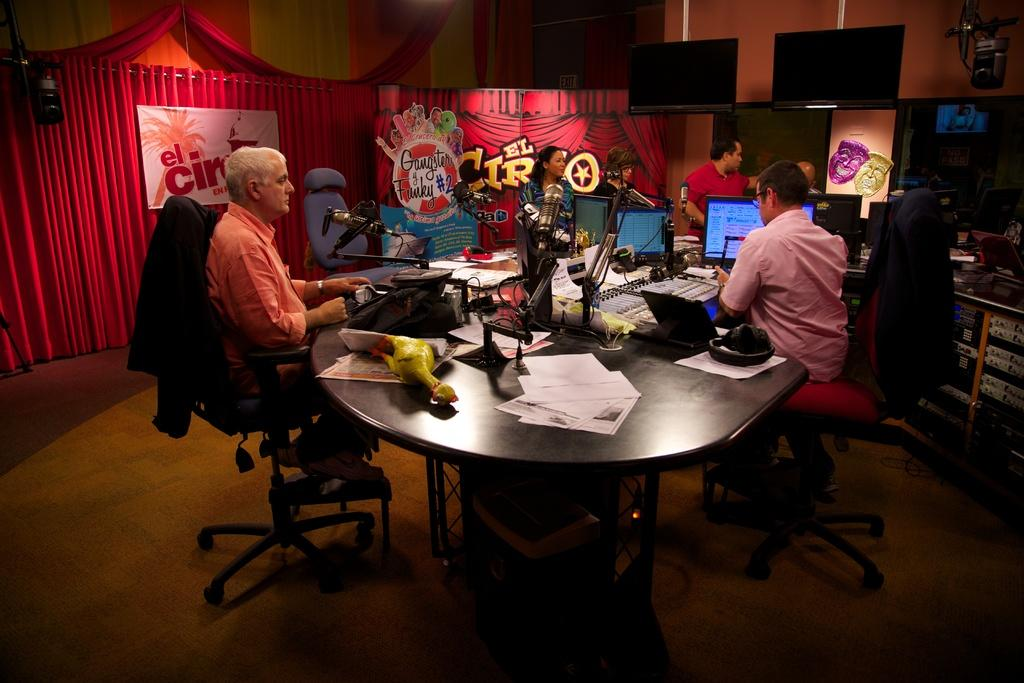What is the main piece of furniture in the image? There is a table in the image. What is on the table? There are many papers on the table. Where are the people sitting in relation to the table? There are people sitting on both the left and right sides of the table. What can be seen in the background of the image? There are curtains visible in the image. What type of beam is being used by the grandfather in the image? There is no grandfather or beam present in the image. How many arrows are in the quiver of the person sitting on the right side of the table? There is no quiver or arrows present in the image. 